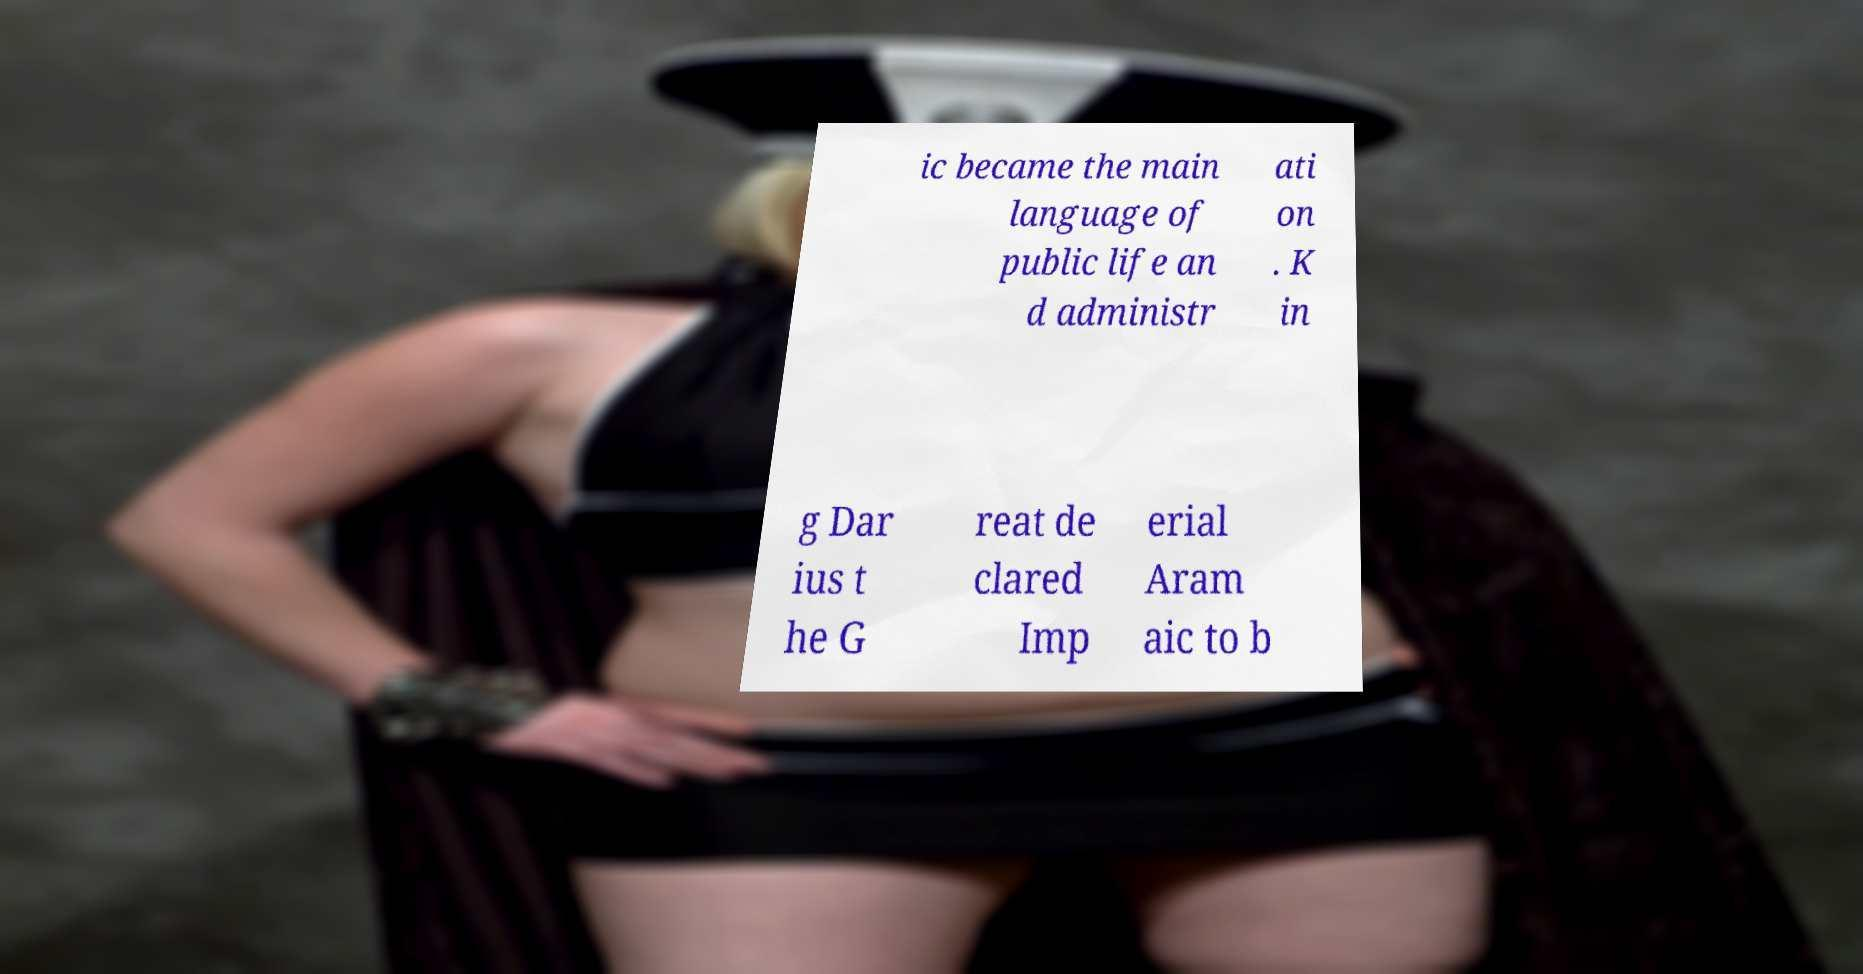Could you extract and type out the text from this image? ic became the main language of public life an d administr ati on . K in g Dar ius t he G reat de clared Imp erial Aram aic to b 